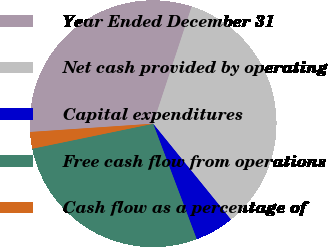Convert chart. <chart><loc_0><loc_0><loc_500><loc_500><pie_chart><fcel>Year Ended December 31<fcel>Net cash provided by operating<fcel>Capital expenditures<fcel>Free cash flow from operations<fcel>Cash flow as a percentage of<nl><fcel>31.14%<fcel>34.08%<fcel>5.11%<fcel>27.5%<fcel>2.17%<nl></chart> 